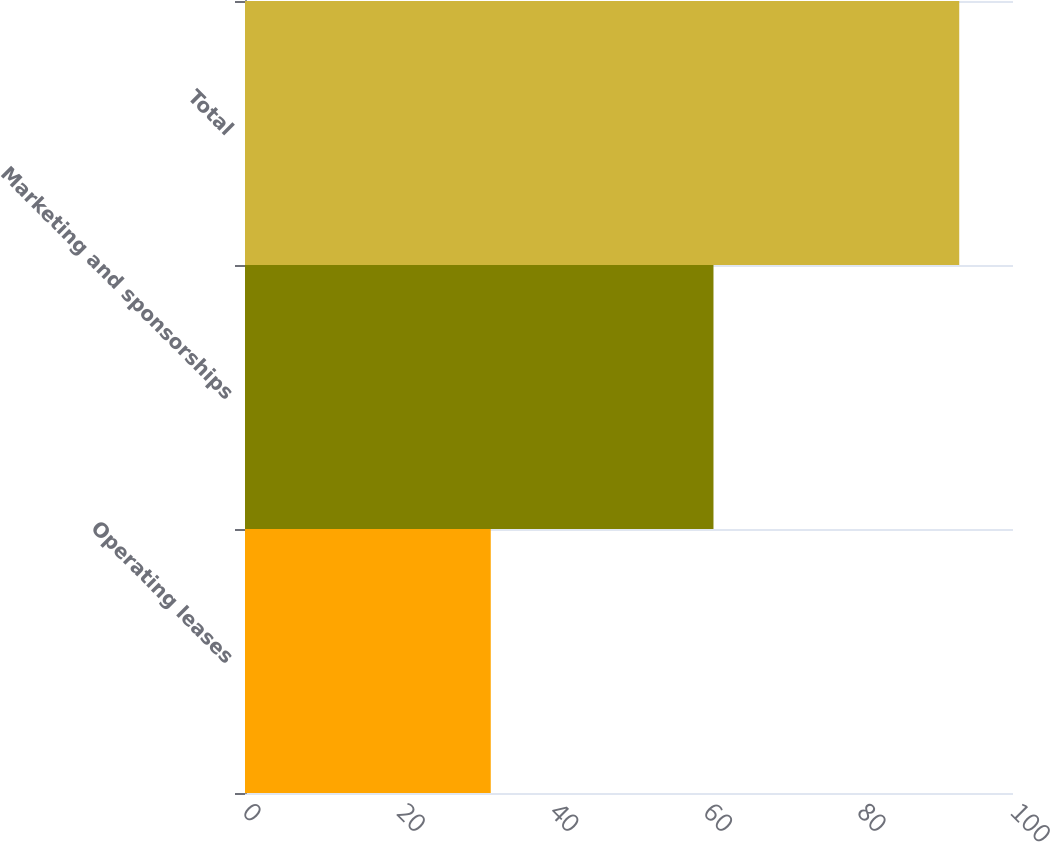Convert chart. <chart><loc_0><loc_0><loc_500><loc_500><bar_chart><fcel>Operating leases<fcel>Marketing and sponsorships<fcel>Total<nl><fcel>32<fcel>61<fcel>93<nl></chart> 